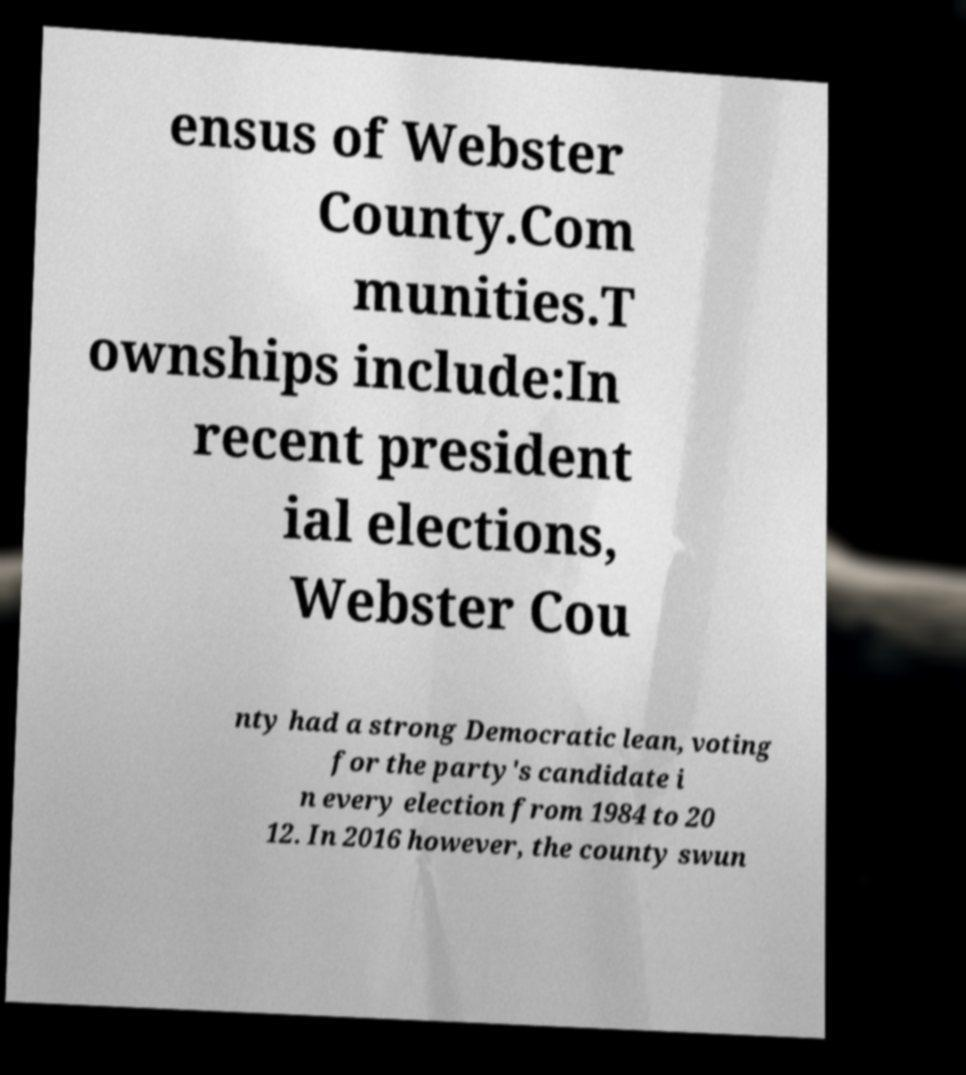There's text embedded in this image that I need extracted. Can you transcribe it verbatim? ensus of Webster County.Com munities.T ownships include:In recent president ial elections, Webster Cou nty had a strong Democratic lean, voting for the party's candidate i n every election from 1984 to 20 12. In 2016 however, the county swun 